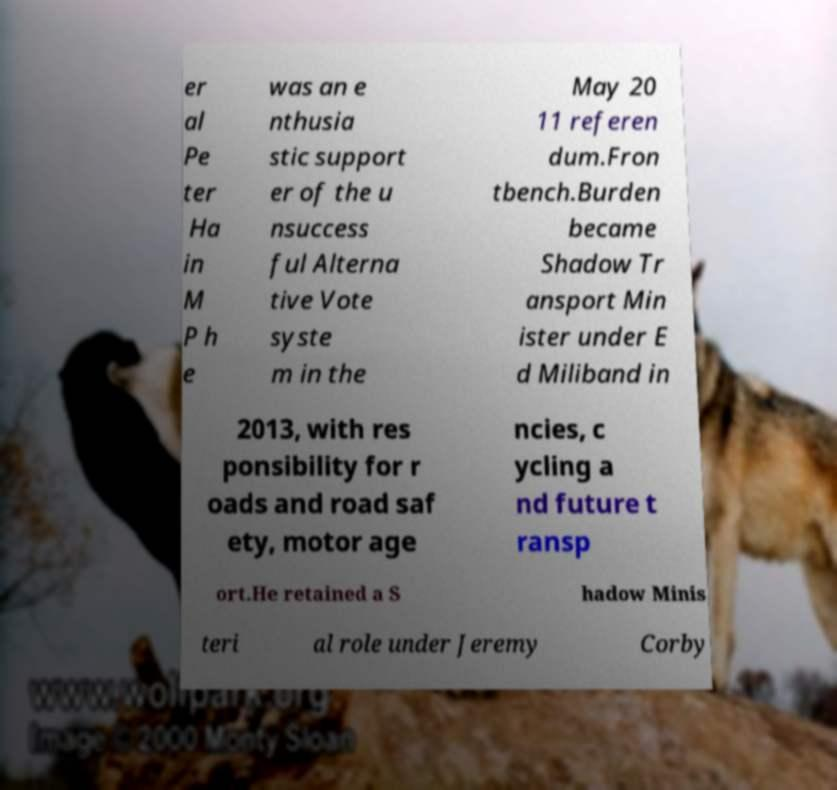For documentation purposes, I need the text within this image transcribed. Could you provide that? er al Pe ter Ha in M P h e was an e nthusia stic support er of the u nsuccess ful Alterna tive Vote syste m in the May 20 11 referen dum.Fron tbench.Burden became Shadow Tr ansport Min ister under E d Miliband in 2013, with res ponsibility for r oads and road saf ety, motor age ncies, c ycling a nd future t ransp ort.He retained a S hadow Minis teri al role under Jeremy Corby 